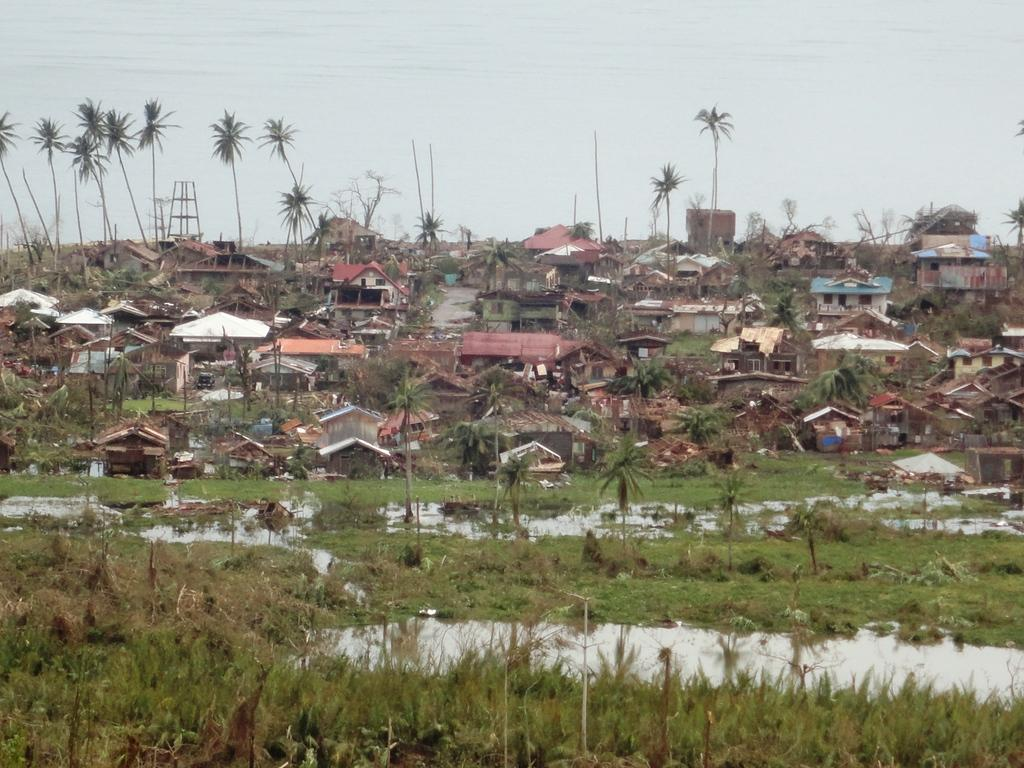What type of structures can be seen in the image? There are houses in the image. What type of vegetation is present in the image? There are trees, plants, and grass in the image. What natural element is visible in the image? There is water visible in the image. What part of the natural environment is visible in the background of the image? The sky is visible in the background of the image. What type of jam is being spread on the sister's toast in the image? There is no sister or toast present in the image, so there is no jam being spread. What type of lumber is being used to build the houses in the image? The image does not provide information about the materials used to build the houses, so it cannot be determined from the image. 